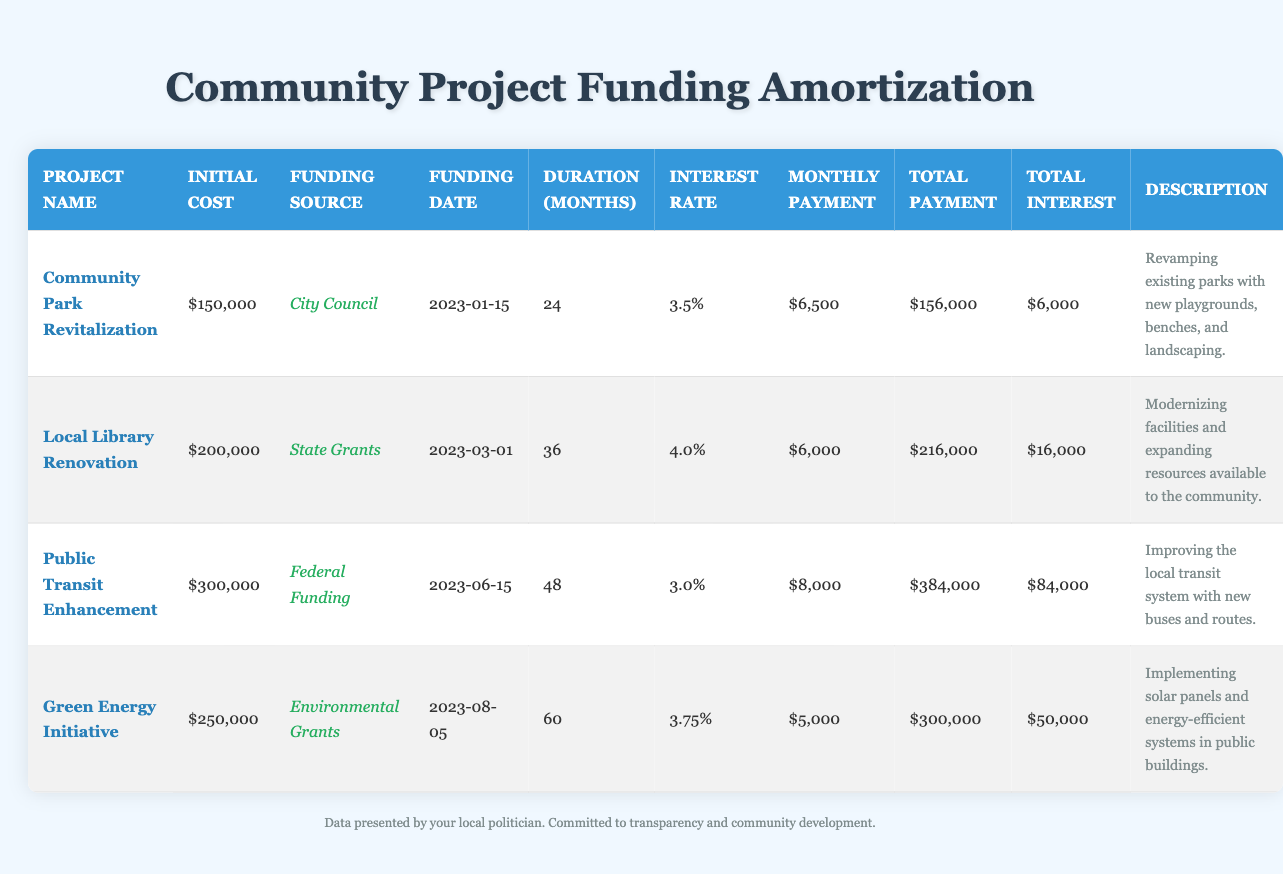What is the initial cost of the Community Park Revitalization project? The initial cost is explicitly listed in the table under the "Initial Cost" column for the row corresponding to the Community Park Revitalization project, which is $150,000.
Answer: $150,000 How long will the Local Library Renovation take to complete? The duration of the Local Library Renovation project is given in the "Duration (Months)" column for that project, which is 36 months.
Answer: 36 months What is the total interest paid on the Public Transit Enhancement project? The total interest is found in the "Total Interest" column for the Public Transit Enhancement project, which shows a total interest of $84,000.
Answer: $84,000 Is the total payment for the Green Energy Initiative greater than the total payment for the Community Park Revitalization? The total payment for the Green Energy Initiative ($300,000) is compared to the total payment for the Community Park Revitalization ($156,000). $300,000 is greater than $156,000, confirming that the statement is true.
Answer: Yes What is the average monthly payment for all projects combined? To find the average monthly payment, sum the monthly payments ($6,500 + $6,000 + $8,000 + $5,000 = $25,500) and divide by the number of projects (4). The average is $25,500 / 4 = $6,375.
Answer: $6,375 Which project has the highest total payment, and what is that amount? The total payments for each project are compared: Community Park Revitalization ($156,000), Local Library Renovation ($216,000), Public Transit Enhancement ($384,000), and Green Energy Initiative ($300,000). The Public Transit Enhancement project has the highest total payment of $384,000.
Answer: Public Transit Enhancement; $384,000 Does the Local Library Renovation have a higher interest rate than the Green Energy Initiative? The interest rates for the Local Library Renovation (4.0%) and the Green Energy Initiative (3.75%) are compared. Since 4.0% is greater than 3.75%, the statement is true.
Answer: Yes How much more total interest is paid on the Public Transit Enhancement project compared to the Community Park Revitalization project? The total interest for the Public Transit Enhancement ($84,000) is subtracted from the total interest for the Community Park Revitalization ($6,000). The difference is $84,000 - $6,000 = $78,000.
Answer: $78,000 